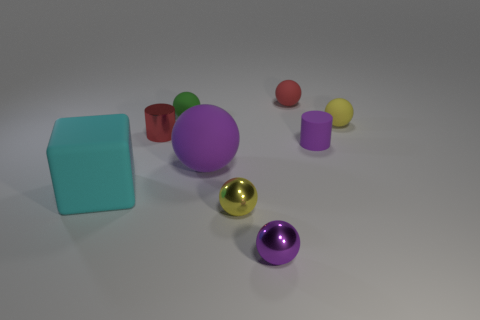Is there a cube of the same color as the big sphere?
Make the answer very short. No. What is the shape of the other yellow thing that is the same size as the yellow matte thing?
Give a very brief answer. Sphere. There is a small cylinder to the right of the tiny shiny cylinder; is its color the same as the large sphere?
Your answer should be compact. Yes. What number of objects are either rubber things on the left side of the purple rubber cylinder or yellow rubber balls?
Your response must be concise. 5. Is the number of yellow spheres that are in front of the tiny red metallic cylinder greater than the number of small green matte balls in front of the block?
Offer a terse response. Yes. Does the red sphere have the same material as the green sphere?
Keep it short and to the point. Yes. What is the shape of the matte thing that is on the left side of the large purple matte ball and behind the purple rubber cylinder?
Offer a terse response. Sphere. There is a cyan thing that is made of the same material as the purple cylinder; what is its shape?
Offer a terse response. Cube. Are there any big blue spheres?
Your answer should be very brief. No. There is a small red thing behind the tiny green thing; are there any tiny purple metallic balls that are behind it?
Offer a very short reply. No. 